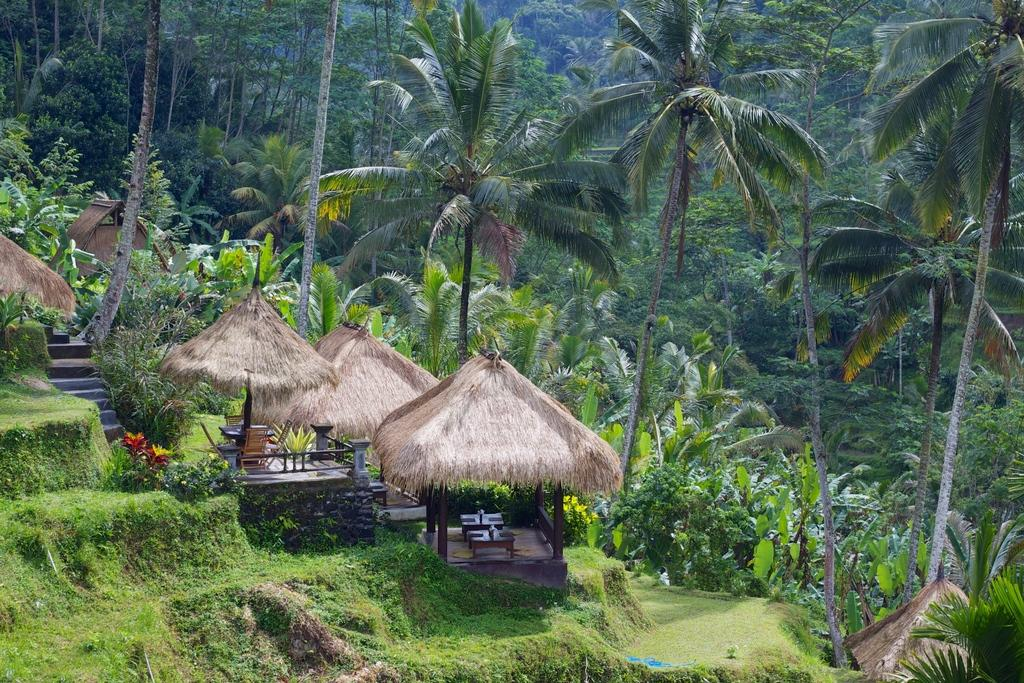What type of structures are in the image? There are huts in the image. What furniture is located under the huts? Tables and chairs are present under the huts. What can be seen behind the huts? There is a group of trees behind the huts. What is visible in the bottom left of the image? Grass and plants are visible in the bottom left of the image. Are there any architectural features in the bottom left of the image? Yes, there are stairs in the bottom left of the image. What type of disgust can be seen on the faces of the people in the image? There are no people present in the image, so it is not possible to determine their facial expressions or emotions. Can you tell me how many guns are visible in the image? There are no guns present in the image. What type of birds are perched on the huts in the image? There are no birds present in the image. 